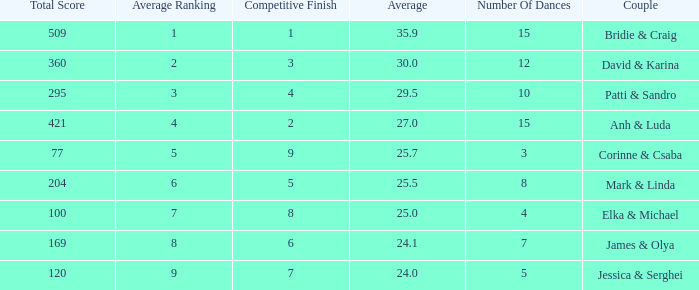What is the total score when 7 is the average ranking? 100.0. 